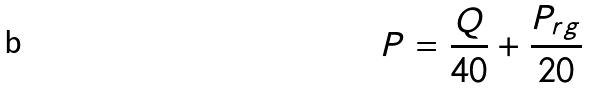Convert formula to latex. <formula><loc_0><loc_0><loc_500><loc_500>P = \frac { Q } { 4 0 } + \frac { P _ { r g } } { 2 0 }</formula> 